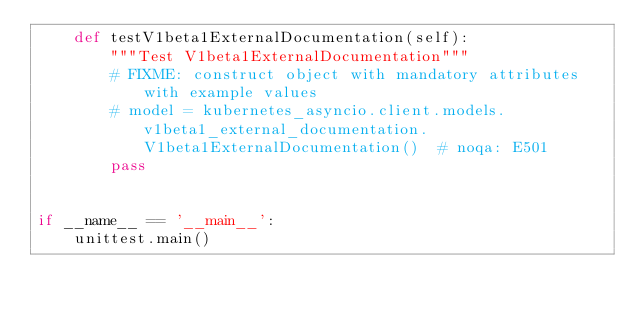<code> <loc_0><loc_0><loc_500><loc_500><_Python_>    def testV1beta1ExternalDocumentation(self):
        """Test V1beta1ExternalDocumentation"""
        # FIXME: construct object with mandatory attributes with example values
        # model = kubernetes_asyncio.client.models.v1beta1_external_documentation.V1beta1ExternalDocumentation()  # noqa: E501
        pass


if __name__ == '__main__':
    unittest.main()
</code> 